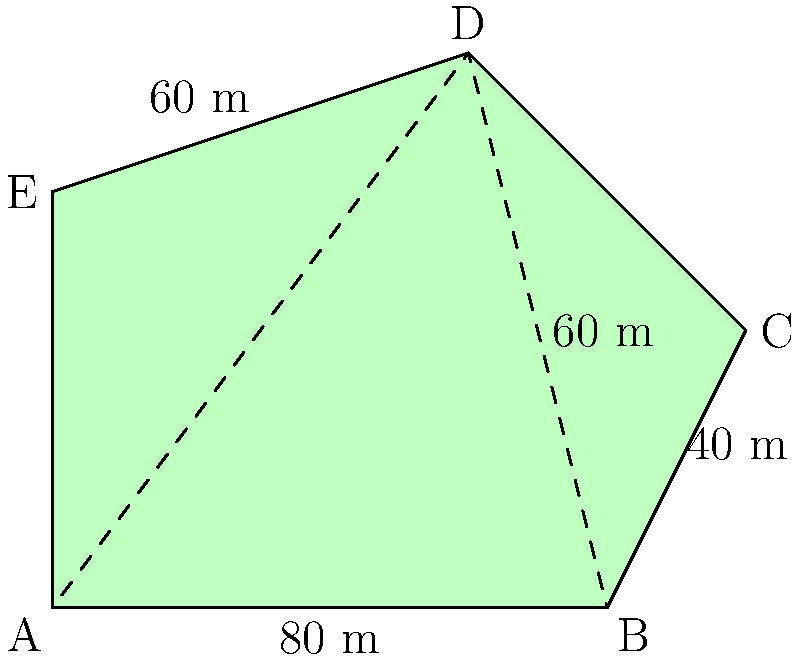You have an irregularly shaped farm plot in Mansura, Louisiana, as shown in the diagram. The plot can be divided into a triangle (ABD) and a trapezoid (BCDE). Given that AB = 80 m, BC = 40 m, and the height of the trapezoid is 60 m, calculate the total area of the farm plot in square meters. Let's approach this step-by-step:

1) First, we'll calculate the area of the triangle ABD:
   Base (AB) = 80 m
   Height (perpendicular from D to AB) = 60 m
   Area of triangle = $\frac{1}{2} \times base \times height$
   $A_{triangle} = \frac{1}{2} \times 80 \times 60 = 2400$ sq m

2) Now, let's calculate the area of the trapezoid BCDE:
   Parallel sides: BC = 40 m, DE = 60 m (given in the diagram)
   Height = 60 m
   Area of trapezoid = $\frac{1}{2}(a+b)h$, where a and b are parallel sides and h is height
   $A_{trapezoid} = \frac{1}{2}(40+60) \times 60 = 3000$ sq m

3) The total area is the sum of these two areas:
   $A_{total} = A_{triangle} + A_{trapezoid}$
   $A_{total} = 2400 + 3000 = 5400$ sq m

Therefore, the total area of the farm plot is 5400 square meters.
Answer: 5400 sq m 